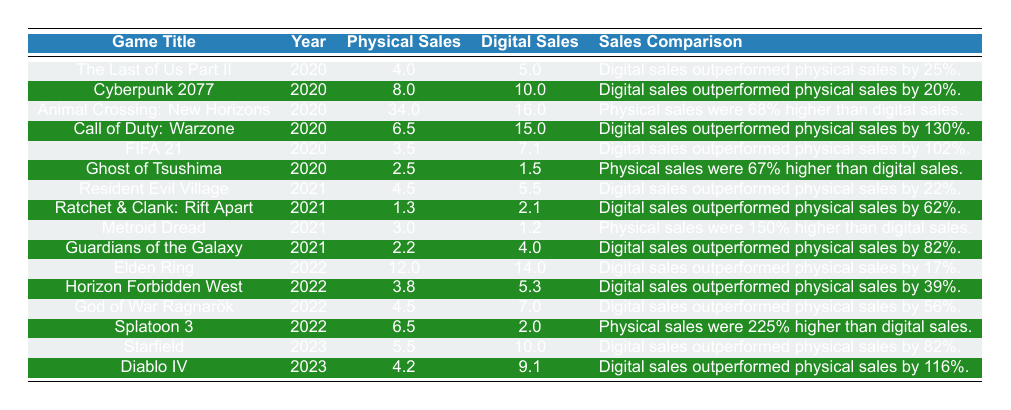What game had the highest physical sales? By inspecting the "Physical Sales" column, the highest value is 34.0, which corresponds to "Animal Crossing: New Horizons."
Answer: Animal Crossing: New Horizons Which game had the lowest digital sales in 2021? In 2021, the digital sales values are 5.5, 2.1, 1.2, and 4.0. The lowest among these is 1.2, associated with "Metroid Dread."
Answer: Metroid Dread Did “Elden Ring” sell more digitally than physically? Checking the sales figures, "Elden Ring" has 12.0 in physical sales and 14.0 in digital sales, thus confirming that digital sales were higher.
Answer: Yes What is the difference in sales between “Call of Duty: Warzone” and “FIFA 21” for digital sales? “Call of Duty: Warzone” had 15.0 in digital sales, and “FIFA 21” had 7.1. Subtracting these gives 15.0 - 7.1 = 7.9.
Answer: 7.9 Which game showed the largest percentage of digital sales outperforming physical sales? Comparing the "Sales Comparison" descriptions, "Call of Duty: Warzone" with a 130% increase has the largest percentage difference in favor of digital sales.
Answer: Call of Duty: Warzone What is the average physical sales of games released in 2022? The physical sales for 2022 include 12.0, 3.8, 4.5, and 6.5. The sum is 12.0 + 3.8 + 4.5 + 6.5 = 26.8, and there are 4 games, so the average is 26.8 / 4 = 6.7.
Answer: 6.7 Did any game in 2020 have physical sales greater than 30 million? The only game from 2020 is "Animal Crossing: New Horizons" with 34.0 physical sales, which is indeed greater than 30 million.
Answer: Yes When comparing 2023 games, which had a higher ratio of digital sales to physical sales? "Starfield" had 10.0 in digital and 5.5 in physical giving a ratio of 10.0 / 5.5 ≈ 1.82, while "Diablo IV" had 9.1 and 4.2, giving 9.1 / 4.2 ≈ 2.17. So, "Diablo IV" has a higher ratio.
Answer: Diablo IV How many games in 2021 sold more digitally than physically? Reviewing the sales for 2021 indicates that "Resident Evil Village," "Ratchet & Clank: Rift Apart," and "Guardians of the Galaxy" had higher digital sales, totaling three games.
Answer: 3 Which year saw the most games with higher physical sales than digital sales? Analyzing 2020, 2021, and 2022, only 2021 has "Metroid Dread" with higher physical sales than digital sales, while games from 2022 and 2020 have more games with higher digital sales.
Answer: 2021 